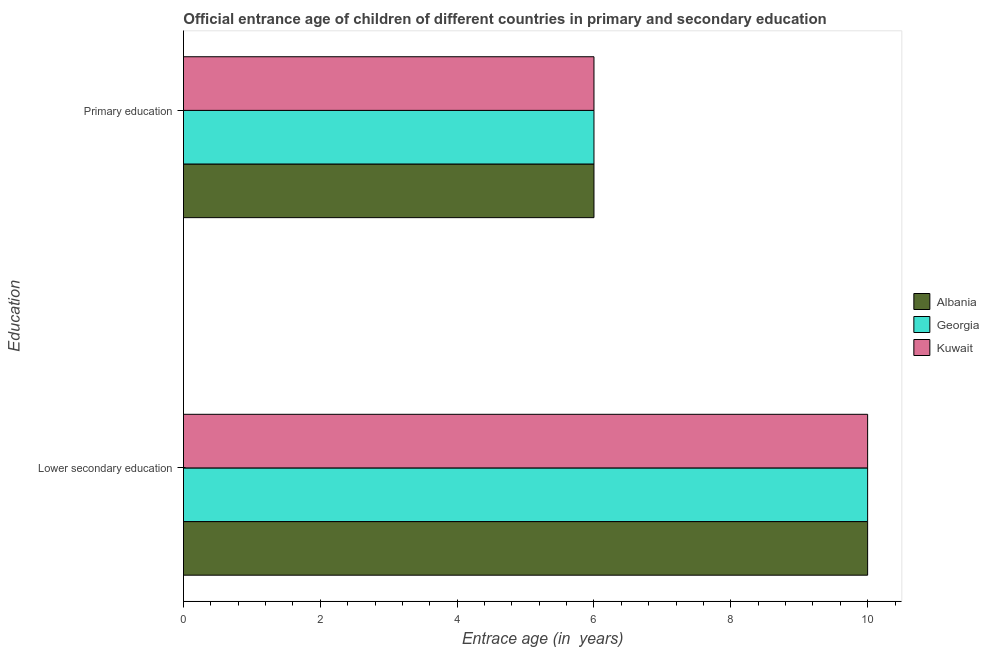Are the number of bars on each tick of the Y-axis equal?
Your answer should be compact. Yes. What is the label of the 1st group of bars from the top?
Keep it short and to the point. Primary education. What is the entrance age of children in lower secondary education in Georgia?
Your response must be concise. 10. Across all countries, what is the maximum entrance age of children in lower secondary education?
Make the answer very short. 10. Across all countries, what is the minimum entrance age of children in lower secondary education?
Provide a succinct answer. 10. In which country was the entrance age of chiildren in primary education maximum?
Your answer should be compact. Albania. In which country was the entrance age of children in lower secondary education minimum?
Your response must be concise. Albania. What is the total entrance age of chiildren in primary education in the graph?
Your response must be concise. 18. What is the difference between the entrance age of chiildren in primary education in Georgia and that in Albania?
Your answer should be compact. 0. What is the difference between the entrance age of children in lower secondary education in Kuwait and the entrance age of chiildren in primary education in Georgia?
Your answer should be compact. 4. What is the difference between the entrance age of chiildren in primary education and entrance age of children in lower secondary education in Albania?
Your answer should be compact. -4. What is the ratio of the entrance age of chiildren in primary education in Kuwait to that in Georgia?
Give a very brief answer. 1. Is the entrance age of children in lower secondary education in Kuwait less than that in Georgia?
Your response must be concise. No. What does the 2nd bar from the top in Primary education represents?
Your answer should be very brief. Georgia. What does the 1st bar from the bottom in Primary education represents?
Your answer should be very brief. Albania. Are all the bars in the graph horizontal?
Give a very brief answer. Yes. How many countries are there in the graph?
Ensure brevity in your answer.  3. Are the values on the major ticks of X-axis written in scientific E-notation?
Offer a terse response. No. How many legend labels are there?
Keep it short and to the point. 3. What is the title of the graph?
Your answer should be very brief. Official entrance age of children of different countries in primary and secondary education. Does "Montenegro" appear as one of the legend labels in the graph?
Provide a short and direct response. No. What is the label or title of the X-axis?
Your answer should be very brief. Entrace age (in  years). What is the label or title of the Y-axis?
Provide a succinct answer. Education. Across all Education, what is the maximum Entrace age (in  years) of Albania?
Give a very brief answer. 10. Across all Education, what is the minimum Entrace age (in  years) in Albania?
Keep it short and to the point. 6. Across all Education, what is the minimum Entrace age (in  years) of Kuwait?
Your answer should be compact. 6. What is the total Entrace age (in  years) in Kuwait in the graph?
Give a very brief answer. 16. What is the difference between the Entrace age (in  years) of Albania in Lower secondary education and that in Primary education?
Keep it short and to the point. 4. What is the difference between the Entrace age (in  years) of Georgia in Lower secondary education and that in Primary education?
Make the answer very short. 4. What is the difference between the Entrace age (in  years) in Kuwait in Lower secondary education and that in Primary education?
Provide a short and direct response. 4. What is the difference between the Entrace age (in  years) in Georgia in Lower secondary education and the Entrace age (in  years) in Kuwait in Primary education?
Offer a very short reply. 4. What is the average Entrace age (in  years) of Georgia per Education?
Provide a succinct answer. 8. What is the difference between the Entrace age (in  years) of Albania and Entrace age (in  years) of Kuwait in Lower secondary education?
Offer a terse response. 0. What is the ratio of the Entrace age (in  years) of Albania in Lower secondary education to that in Primary education?
Your answer should be compact. 1.67. What is the ratio of the Entrace age (in  years) of Georgia in Lower secondary education to that in Primary education?
Offer a terse response. 1.67. What is the difference between the highest and the second highest Entrace age (in  years) in Georgia?
Offer a very short reply. 4. 